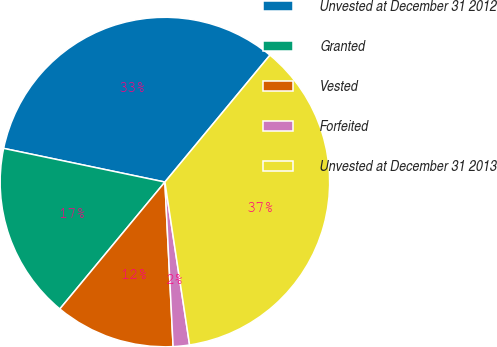Convert chart to OTSL. <chart><loc_0><loc_0><loc_500><loc_500><pie_chart><fcel>Unvested at December 31 2012<fcel>Granted<fcel>Vested<fcel>Forfeited<fcel>Unvested at December 31 2013<nl><fcel>32.73%<fcel>17.27%<fcel>11.8%<fcel>1.6%<fcel>36.6%<nl></chart> 